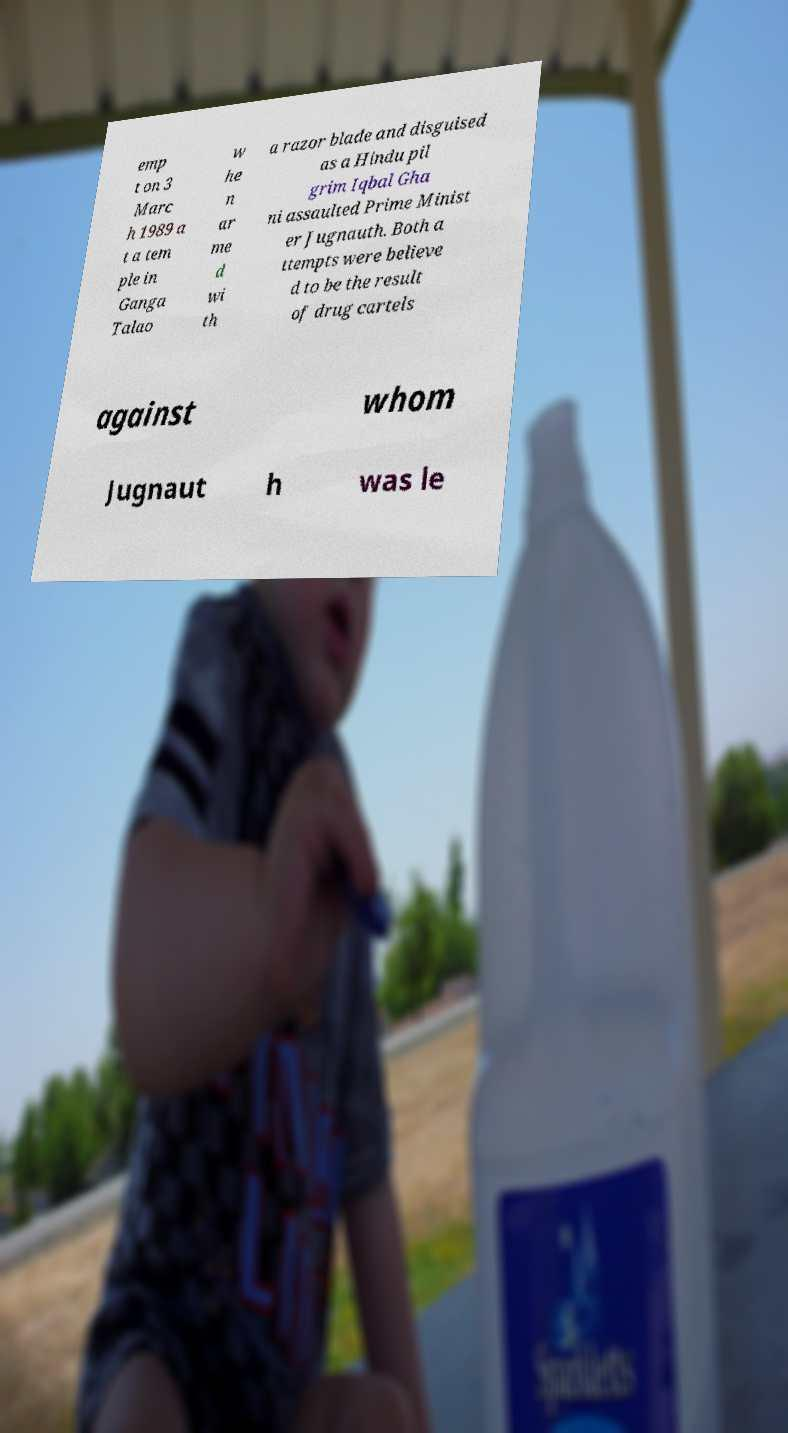I need the written content from this picture converted into text. Can you do that? emp t on 3 Marc h 1989 a t a tem ple in Ganga Talao w he n ar me d wi th a razor blade and disguised as a Hindu pil grim Iqbal Gha ni assaulted Prime Minist er Jugnauth. Both a ttempts were believe d to be the result of drug cartels against whom Jugnaut h was le 